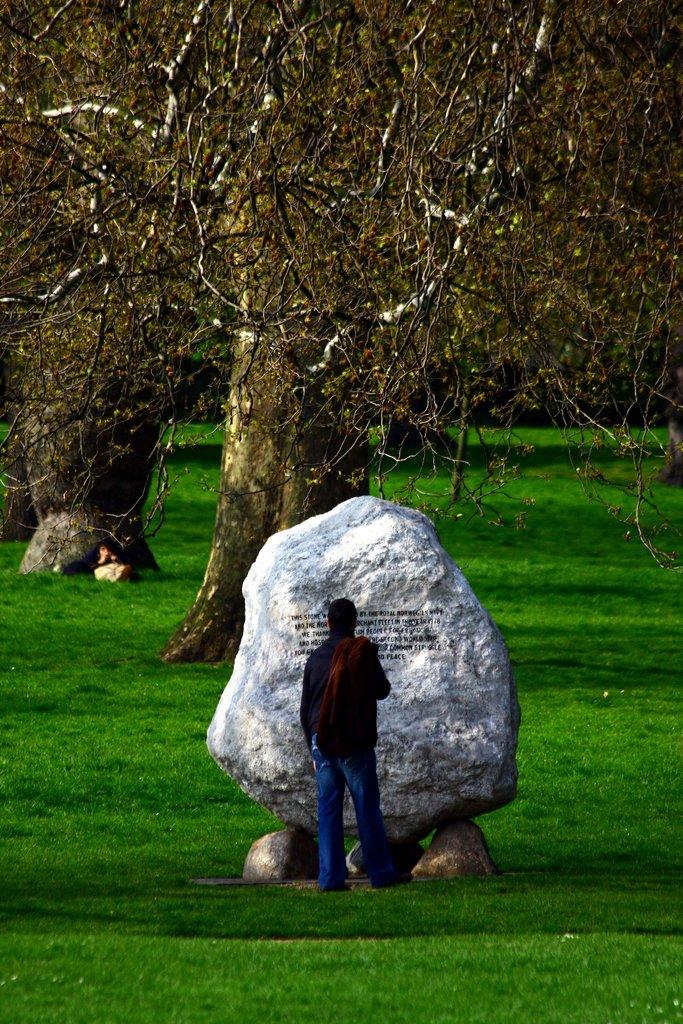What is the main subject of the image? There is a person standing in the image. What type of terrain is visible in the image? There is grass and rocks in the image. What can be seen in the background of the image? There are trees in the background of the image. What type of eggs can be seen near the seashore in the image? There is no seashore or eggs present in the image; it features a person standing in a grassy area with rocks and trees in the background. 